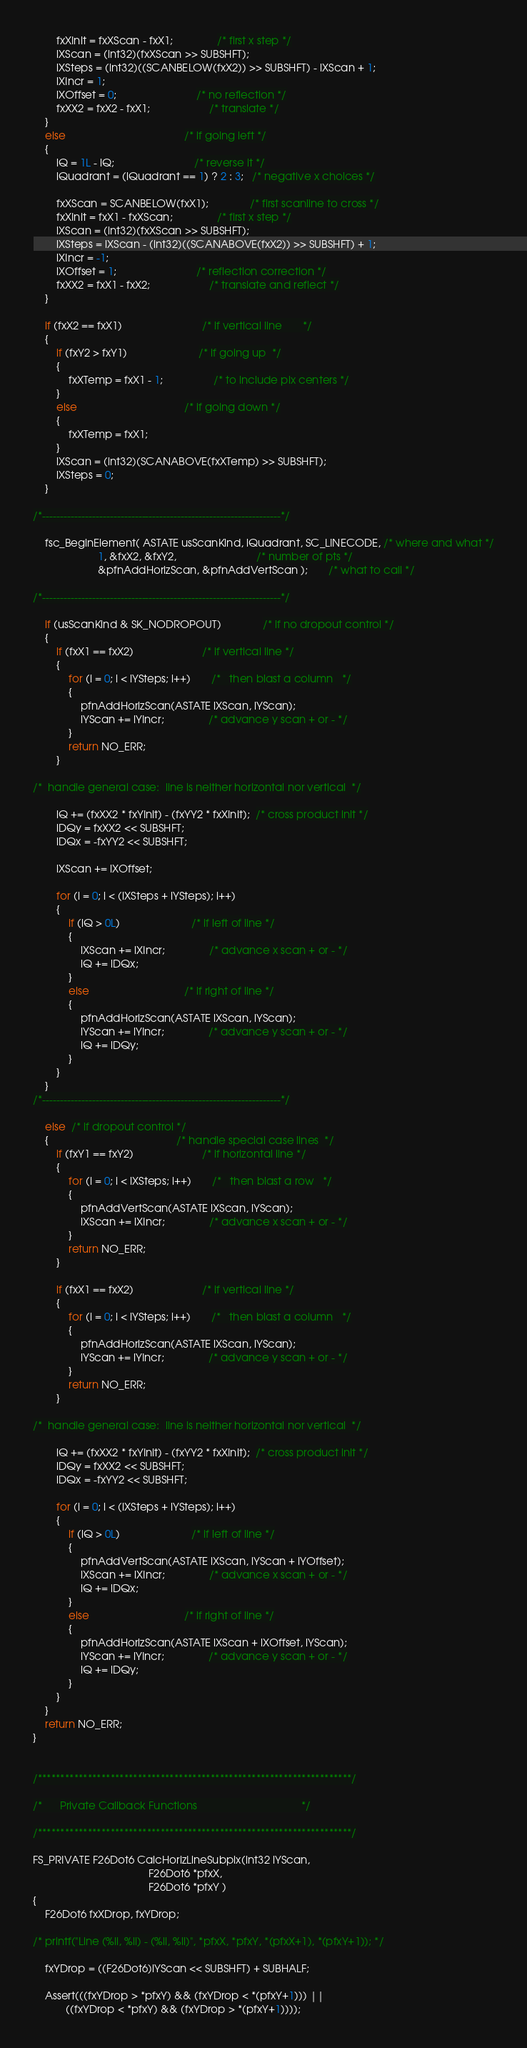Convert code to text. <code><loc_0><loc_0><loc_500><loc_500><_C_>		fxXInit = fxXScan - fxX1;               /* first x step */
		lXScan = (int32)(fxXScan >> SUBSHFT);
		lXSteps = (int32)((SCANBELOW(fxX2)) >> SUBSHFT) - lXScan + 1;
		lXIncr = 1;        
		lXOffset = 0;                           /* no reflection */
		fxXX2 = fxX2 - fxX1;                    /* translate */
	}
	else                                        /* if going left */
	{
		lQ = 1L - lQ;                           /* reverse it */
		lQuadrant = (lQuadrant == 1) ? 2 : 3;   /* negative x choices */

		fxXScan = SCANBELOW(fxX1);              /* first scanline to cross */
		fxXInit = fxX1 - fxXScan;               /* first x step */
		lXScan = (int32)(fxXScan >> SUBSHFT);
		lXSteps = lXScan - (int32)((SCANABOVE(fxX2)) >> SUBSHFT) + 1;
		lXIncr = -1;        
		lXOffset = 1;                           /* reflection correction */
		fxXX2 = fxX1 - fxX2;                    /* translate and reflect */
	}
	
	if (fxX2 == fxX1)                           /* if vertical line       */
	{
		if (fxY2 > fxY1)                        /* if going up  */
		{
			fxXTemp = fxX1 - 1;                 /* to include pix centers */
		}
		else                                    /* if going down */
		{
			fxXTemp = fxX1;          
		}
		lXScan = (int32)(SCANABOVE(fxXTemp) >> SUBSHFT);
		lXSteps = 0;
	}

/*-------------------------------------------------------------------*/
	
	fsc_BeginElement( ASTATE usScanKind, lQuadrant, SC_LINECODE, /* where and what */
					  1, &fxX2, &fxY2,                           /* number of pts */
					  &pfnAddHorizScan, &pfnAddVertScan );       /* what to call */

/*-------------------------------------------------------------------*/

	if (usScanKind & SK_NODROPOUT)              /* if no dropout control */
	{
		if (fxX1 == fxX2)                       /* if vertical line */
		{
			for (i = 0; i < lYSteps; i++)       /*   then blast a column   */
			{
				pfnAddHorizScan(ASTATE lXScan, lYScan);
				lYScan += lYIncr;               /* advance y scan + or - */
			}
			return NO_ERR;
		}
		
/*  handle general case:  line is neither horizontal nor vertical  */

		lQ += (fxXX2 * fxYInit) - (fxYY2 * fxXInit);  /* cross product init */
		lDQy = fxXX2 << SUBSHFT;
		lDQx = -fxYY2 << SUBSHFT;
																	
		lXScan += lXOffset;

		for (i = 0; i < (lXSteps + lYSteps); i++)
		{
			if (lQ > 0L)                        /* if left of line */
			{
				lXScan += lXIncr;               /* advance x scan + or - */
				lQ += lDQx;           
			}
			else                                /* if right of line */
			{
				pfnAddHorizScan(ASTATE lXScan, lYScan);
				lYScan += lYIncr;               /* advance y scan + or - */
				lQ += lDQy;
			}
		}
	}
/*-------------------------------------------------------------------*/
	
	else  /* if dropout control */
	{                                           /* handle special case lines  */
		if (fxY1 == fxY2)                       /* if horizontal line */
		{
			for (i = 0; i < lXSteps; i++)       /*   then blast a row   */
			{
				pfnAddVertScan(ASTATE lXScan, lYScan);
				lXScan += lXIncr;               /* advance x scan + or - */
			}
			return NO_ERR;
		}

		if (fxX1 == fxX2)                       /* if vertical line */
		{
			for (i = 0; i < lYSteps; i++)       /*   then blast a column   */
			{
				pfnAddHorizScan(ASTATE lXScan, lYScan);
				lYScan += lYIncr;               /* advance y scan + or - */
			}
			return NO_ERR;
		}
		
/*  handle general case:  line is neither horizontal nor vertical  */

		lQ += (fxXX2 * fxYInit) - (fxYY2 * fxXInit);  /* cross product init */
		lDQy = fxXX2 << SUBSHFT;
		lDQx = -fxYY2 << SUBSHFT;
																	
		for (i = 0; i < (lXSteps + lYSteps); i++)
		{
			if (lQ > 0L)                        /* if left of line */
			{
				pfnAddVertScan(ASTATE lXScan, lYScan + lYOffset);
				lXScan += lXIncr;               /* advance x scan + or - */
				lQ += lDQx;           
			}
			else                                /* if right of line */
			{
				pfnAddHorizScan(ASTATE lXScan + lXOffset, lYScan);
				lYScan += lYIncr;               /* advance y scan + or - */
				lQ += lDQy;
			}
		}
	}
	return NO_ERR;
}


/*********************************************************************/

/*      Private Callback Functions                                   */

/*********************************************************************/

FS_PRIVATE F26Dot6 CalcHorizLineSubpix(int32 lYScan, 
									   F26Dot6 *pfxX, 
									   F26Dot6 *pfxY )
{
	F26Dot6 fxXDrop, fxYDrop;

/* printf("Line (%li, %li) - (%li, %li)", *pfxX, *pfxY, *(pfxX+1), *(pfxY+1)); */

	fxYDrop = ((F26Dot6)lYScan << SUBSHFT) + SUBHALF;
	
	Assert(((fxYDrop > *pfxY) && (fxYDrop < *(pfxY+1))) ||
		   ((fxYDrop < *pfxY) && (fxYDrop > *(pfxY+1))));
</code> 